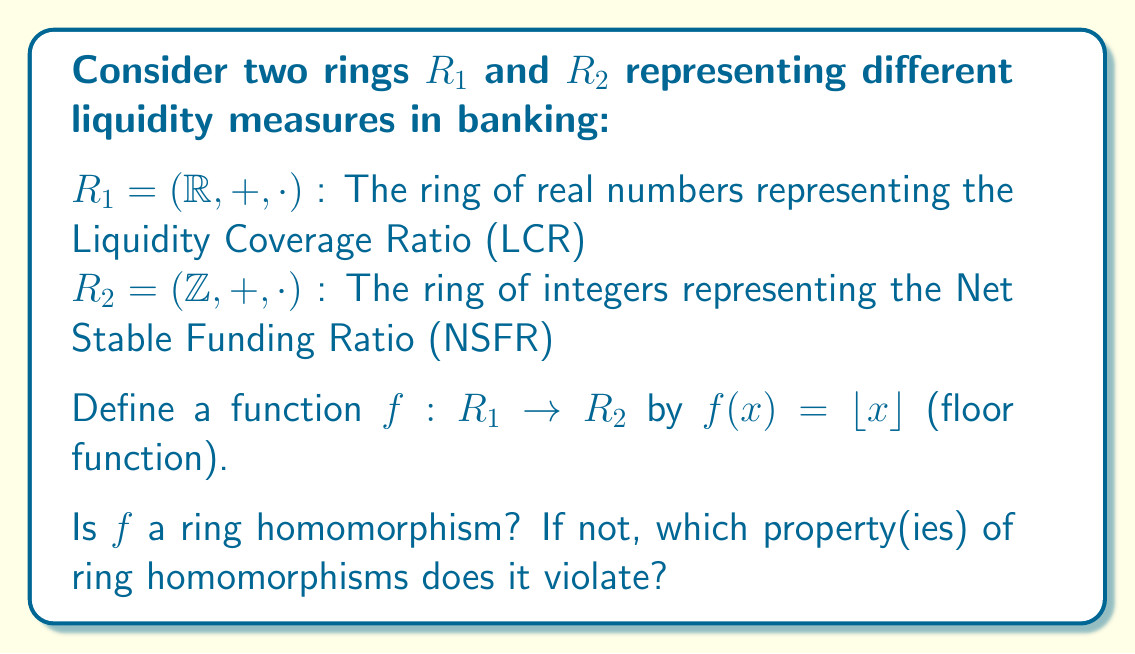Give your solution to this math problem. To determine if $f$ is a ring homomorphism, we need to check if it satisfies the three properties of ring homomorphisms:

1. Preserves addition: $f(a+b) = f(a) + f(b)$ for all $a,b \in R_1$
2. Preserves multiplication: $f(a \cdot b) = f(a) \cdot f(b)$ for all $a,b \in R_1$
3. Maps the multiplicative identity: $f(1_{R_1}) = 1_{R_2}$

Let's check each property:

1. Addition:
Consider $a = 3.7$ and $b = 2.5$
$f(a+b) = f(3.7 + 2.5) = f(6.2) = 6$
$f(a) + f(b) = f(3.7) + f(2.5) = 3 + 2 = 5$
Since $f(a+b) \neq f(a) + f(b)$, the addition property is violated.

2. Multiplication:
Consider $a = 2.5$ and $b = 2.2$
$f(a \cdot b) = f(2.5 \cdot 2.2) = f(5.5) = 5$
$f(a) \cdot f(b) = f(2.5) \cdot f(2.2) = 2 \cdot 2 = 4$
Since $f(a \cdot b) \neq f(a) \cdot f(b)$, the multiplication property is violated.

3. Multiplicative identity:
$f(1_{R_1}) = f(1) = 1 = 1_{R_2}$
This property is satisfied.

Since $f$ violates both the addition and multiplication preservation properties, it is not a ring homomorphism.
Answer: $f$ is not a ring homomorphism; it violates addition and multiplication preservation. 